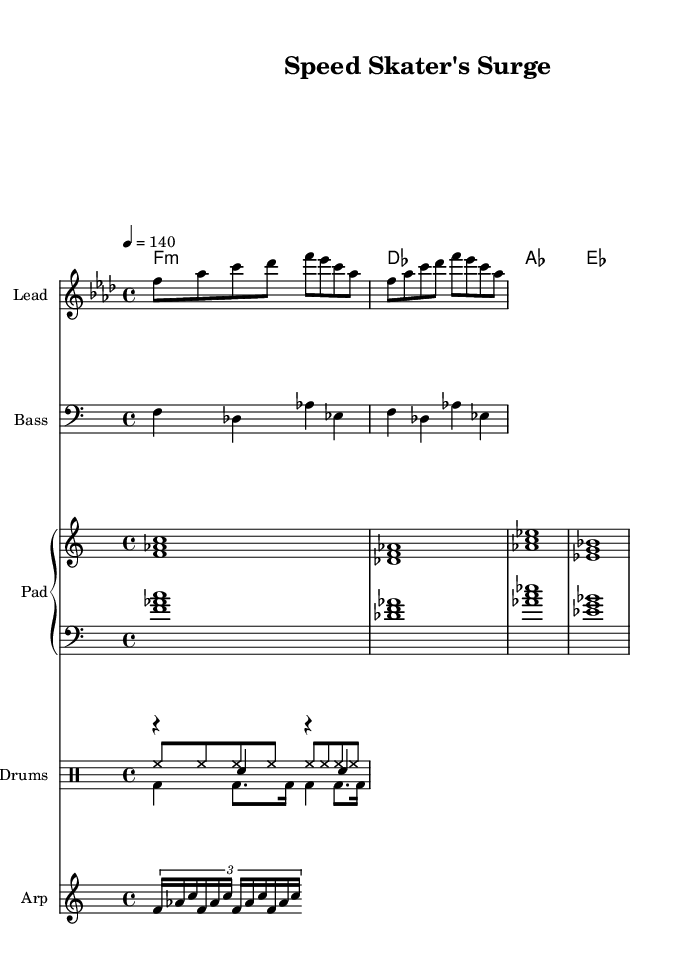What is the key signature of this music? The key signature is indicated at the beginning of the score, and it shows B♭ and E♭, which corresponds to the key of F minor.
Answer: F minor What is the time signature of this music? The time signature is located at the beginning of the score, marked as 4/4, indicating four beats per measure and a quarter note gets one beat.
Answer: 4/4 What is the tempo marking for this piece? The tempo marking is found near the beginning of the score, where it shows "4 = 140", meaning there are 140 quarter-note beats per minute.
Answer: 140 Which instrument plays the melody? The melody is specified to be played by the "Lead" instrument, as indicated directly in the staff header.
Answer: Lead What rhythmic pattern is being used for the drums? The drum patterns are displayed in separate drum voices; the kick, snare, and hi-hat all have distinctive notations. The kick drum has a repeated pattern of four quarter notes followed by various eighth notes and sixteenth notes.
Answer: Kick pattern How many beats are there in one measure? The time signature of 4/4 indicates that each measure contains four beats, with a quarter note receiving one beat.
Answer: Four beats What type of electronic sound is emphasized in this music? The presence of a synthesized bass and arpeggiated notes alongside a steady drum pattern suggests an upbeat electronic dance music style, which is common for workout sessions.
Answer: Upbeat electronic dance 